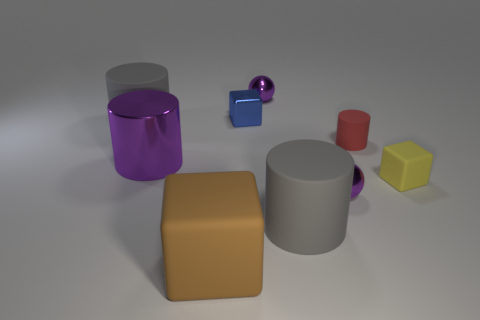There is a tiny matte cylinder; how many big matte cylinders are in front of it? In the arrangement shown, there appears to be one larger matte cylinder positioned in front of the smaller matte cylinder from the perspective of the viewer. 